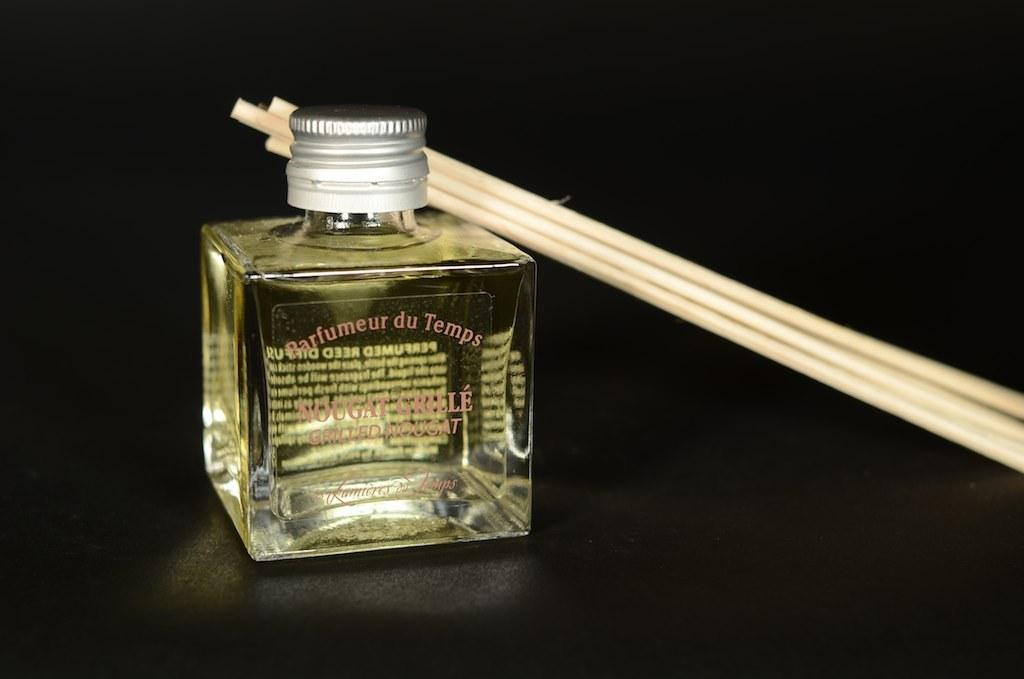Provide a one-sentence caption for the provided image. A bottle on a table labeled Barfumeur du Temps with sticks leaning on it. 